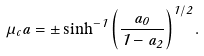<formula> <loc_0><loc_0><loc_500><loc_500>\mu _ { c } a = \pm \sinh ^ { - 1 } \left ( \frac { a _ { 0 } } { 1 - a _ { 2 } } \right ) ^ { 1 / 2 } .</formula> 